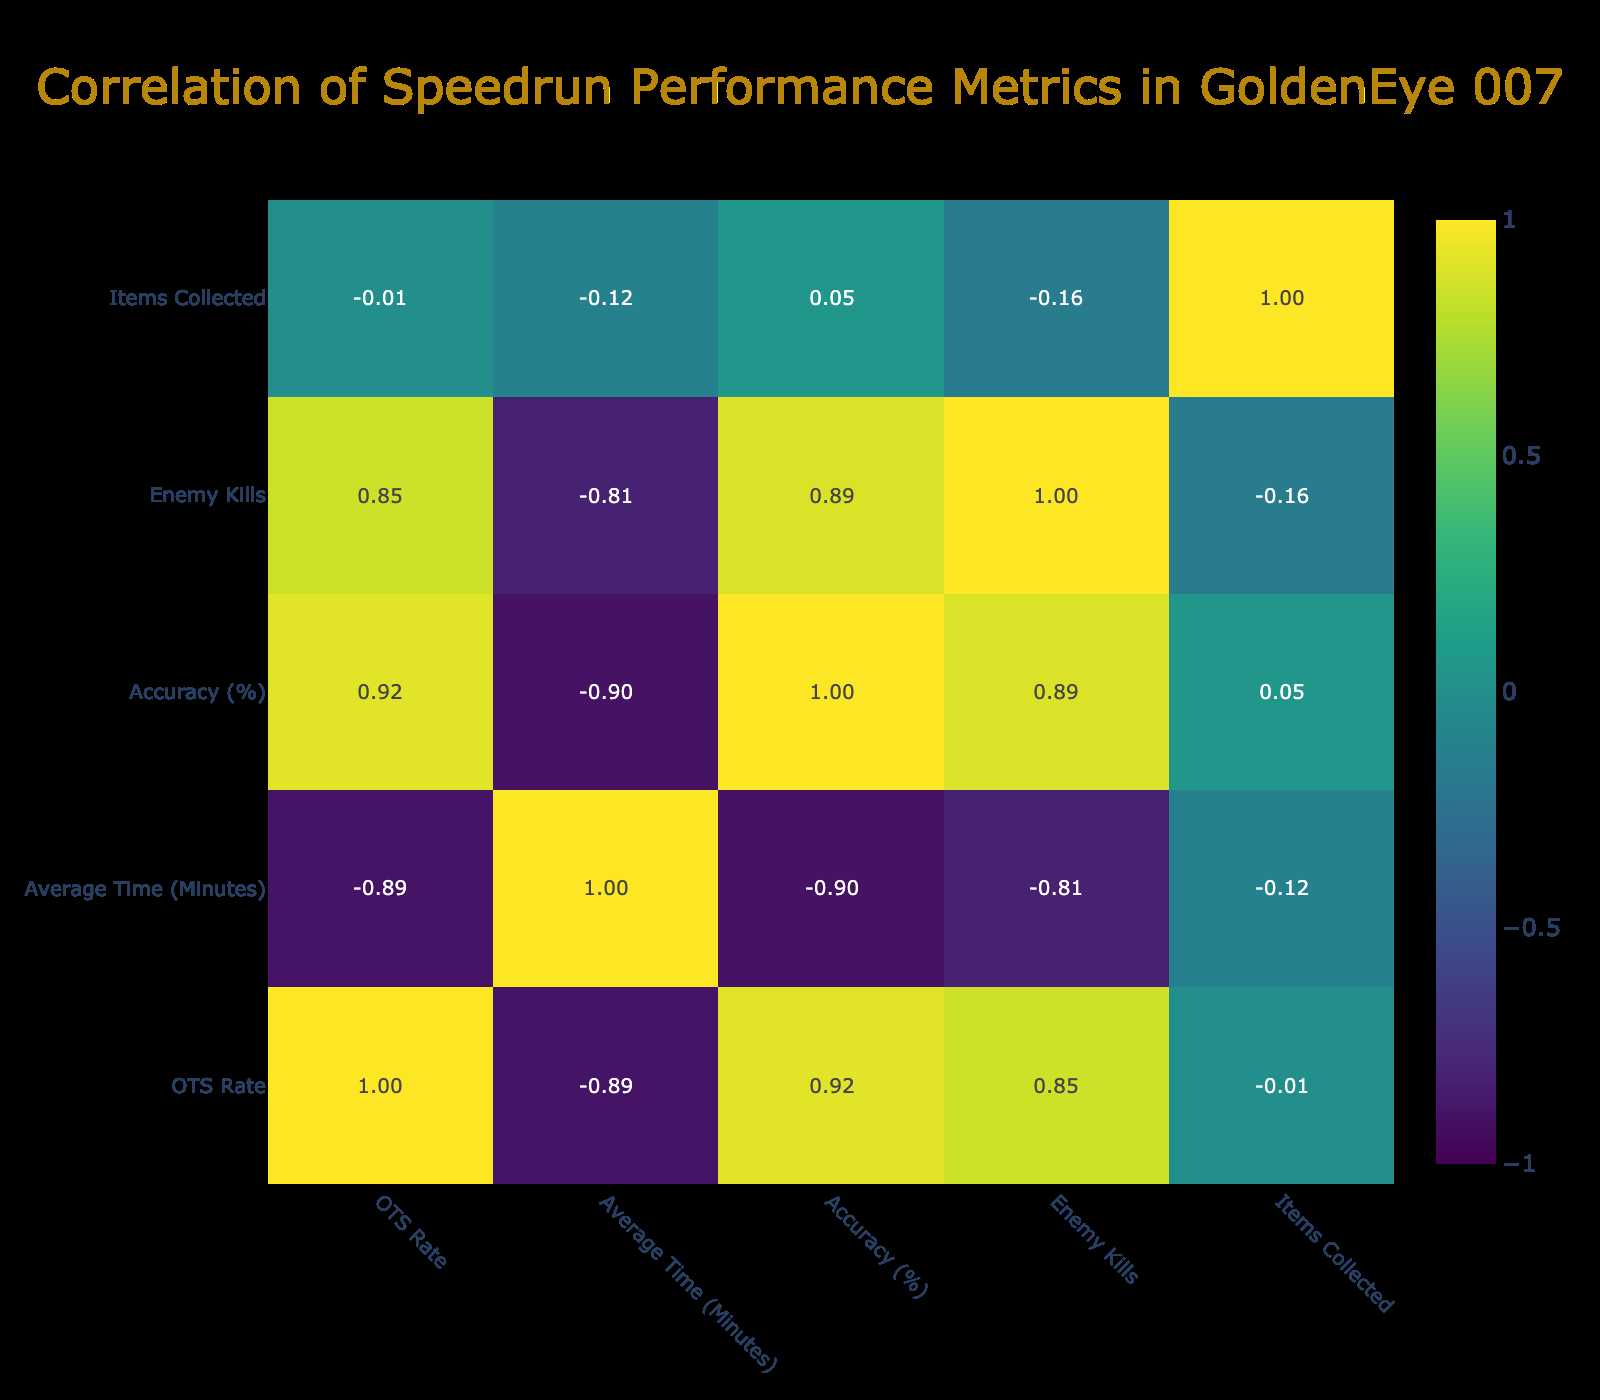What character has the highest OTS Rate? The OTS Rate is listed in the table for each character. Inspecting the data, Oddjob has an OTS Rate of 0.92, which is the highest among all characters.
Answer: Oddjob What is the average accuracy percentage for all characters combined? To find the average accuracy, we first sum the accuracy percentages of all characters: 90 + 88 + 85 + 92 + 95 + 87 + 89 + 84 = 720. There are 8 characters, so we divide by 8: 720 / 8 = 90.
Answer: 90 Which character has the lowest average time? Comparing the average time for each character, Oddjob has an average time of 29 minutes, which is lower than the others.
Answer: Oddjob Is it true that Natalya Simonova has a higher average time than Alec Trevelyan? Natalya Simonova has an average time of 35 minutes, while Alec Trevelyan has an average time of 32 minutes. Since 35 is greater than 32, the statement is true.
Answer: Yes What is the difference in enemy kills between the character with the most kills and the character with the least kills? Inspecting the enemy kills: Oddjob has 35 kills (most), while Trevelyan (006) has 18 kills (least). The difference is 35 - 18 = 17.
Answer: 17 Which character has a lower accuracy percentage than the average accuracy? The average accuracy calculated earlier is 90. Checking character accuracies, both Alec Trevelyan (88) and Jaws (87) are lower than the average of 90.
Answer: Alec Trevelyan and Jaws What is the total number of items collected by all characters? To find the total items collected, we sum the items for each character: 15 + 10 + 12 + 14 + 8 + 11 + 13 + 9 = 92.
Answer: 92 If we consider only the top three characters by OTS Rate, what is their average average time? The top three characters by OTS Rate are Oddjob (29 min), James Bond (30 min), and Xenia Onatopp (31 min). To find the average time, we sum them: 29 + 30 + 31 = 90, and then divide by 3: 90 / 3 = 30.
Answer: 30 